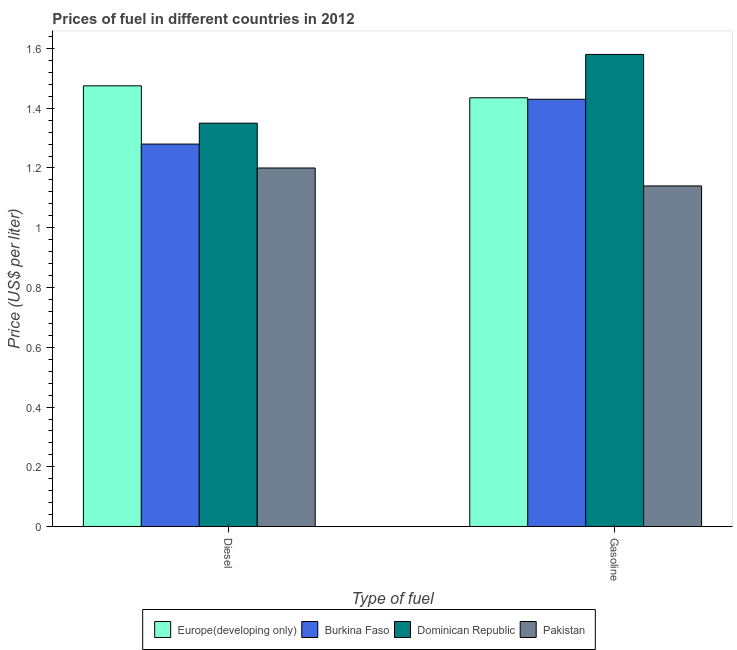How many different coloured bars are there?
Your response must be concise. 4. Are the number of bars per tick equal to the number of legend labels?
Ensure brevity in your answer.  Yes. How many bars are there on the 1st tick from the right?
Make the answer very short. 4. What is the label of the 2nd group of bars from the left?
Your answer should be compact. Gasoline. What is the diesel price in Dominican Republic?
Ensure brevity in your answer.  1.35. Across all countries, what is the maximum gasoline price?
Provide a succinct answer. 1.58. Across all countries, what is the minimum diesel price?
Your response must be concise. 1.2. In which country was the gasoline price maximum?
Provide a succinct answer. Dominican Republic. What is the total diesel price in the graph?
Your answer should be compact. 5.31. What is the difference between the gasoline price in Europe(developing only) and that in Dominican Republic?
Your answer should be compact. -0.15. What is the difference between the diesel price in Dominican Republic and the gasoline price in Europe(developing only)?
Provide a succinct answer. -0.08. What is the average diesel price per country?
Provide a succinct answer. 1.33. What is the difference between the diesel price and gasoline price in Pakistan?
Your response must be concise. 0.06. In how many countries, is the diesel price greater than 0.12 US$ per litre?
Keep it short and to the point. 4. What is the ratio of the gasoline price in Dominican Republic to that in Europe(developing only)?
Give a very brief answer. 1.1. What does the 1st bar from the left in Diesel represents?
Give a very brief answer. Europe(developing only). What does the 3rd bar from the right in Gasoline represents?
Your answer should be very brief. Burkina Faso. How many countries are there in the graph?
Provide a succinct answer. 4. What is the difference between two consecutive major ticks on the Y-axis?
Provide a succinct answer. 0.2. Does the graph contain any zero values?
Your response must be concise. No. What is the title of the graph?
Provide a short and direct response. Prices of fuel in different countries in 2012. Does "Least developed countries" appear as one of the legend labels in the graph?
Offer a terse response. No. What is the label or title of the X-axis?
Provide a short and direct response. Type of fuel. What is the label or title of the Y-axis?
Keep it short and to the point. Price (US$ per liter). What is the Price (US$ per liter) of Europe(developing only) in Diesel?
Offer a very short reply. 1.48. What is the Price (US$ per liter) of Burkina Faso in Diesel?
Offer a very short reply. 1.28. What is the Price (US$ per liter) in Dominican Republic in Diesel?
Provide a short and direct response. 1.35. What is the Price (US$ per liter) of Pakistan in Diesel?
Your answer should be compact. 1.2. What is the Price (US$ per liter) of Europe(developing only) in Gasoline?
Offer a very short reply. 1.44. What is the Price (US$ per liter) of Burkina Faso in Gasoline?
Provide a short and direct response. 1.43. What is the Price (US$ per liter) of Dominican Republic in Gasoline?
Give a very brief answer. 1.58. What is the Price (US$ per liter) in Pakistan in Gasoline?
Your answer should be very brief. 1.14. Across all Type of fuel, what is the maximum Price (US$ per liter) in Europe(developing only)?
Keep it short and to the point. 1.48. Across all Type of fuel, what is the maximum Price (US$ per liter) in Burkina Faso?
Your response must be concise. 1.43. Across all Type of fuel, what is the maximum Price (US$ per liter) in Dominican Republic?
Offer a very short reply. 1.58. Across all Type of fuel, what is the maximum Price (US$ per liter) in Pakistan?
Ensure brevity in your answer.  1.2. Across all Type of fuel, what is the minimum Price (US$ per liter) in Europe(developing only)?
Your response must be concise. 1.44. Across all Type of fuel, what is the minimum Price (US$ per liter) in Burkina Faso?
Provide a short and direct response. 1.28. Across all Type of fuel, what is the minimum Price (US$ per liter) in Dominican Republic?
Keep it short and to the point. 1.35. Across all Type of fuel, what is the minimum Price (US$ per liter) of Pakistan?
Ensure brevity in your answer.  1.14. What is the total Price (US$ per liter) of Europe(developing only) in the graph?
Keep it short and to the point. 2.91. What is the total Price (US$ per liter) in Burkina Faso in the graph?
Your answer should be very brief. 2.71. What is the total Price (US$ per liter) of Dominican Republic in the graph?
Keep it short and to the point. 2.93. What is the total Price (US$ per liter) of Pakistan in the graph?
Your answer should be very brief. 2.34. What is the difference between the Price (US$ per liter) of Dominican Republic in Diesel and that in Gasoline?
Your answer should be very brief. -0.23. What is the difference between the Price (US$ per liter) in Europe(developing only) in Diesel and the Price (US$ per liter) in Burkina Faso in Gasoline?
Your answer should be compact. 0.04. What is the difference between the Price (US$ per liter) of Europe(developing only) in Diesel and the Price (US$ per liter) of Dominican Republic in Gasoline?
Your response must be concise. -0.1. What is the difference between the Price (US$ per liter) in Europe(developing only) in Diesel and the Price (US$ per liter) in Pakistan in Gasoline?
Provide a short and direct response. 0.34. What is the difference between the Price (US$ per liter) in Burkina Faso in Diesel and the Price (US$ per liter) in Dominican Republic in Gasoline?
Offer a terse response. -0.3. What is the difference between the Price (US$ per liter) of Burkina Faso in Diesel and the Price (US$ per liter) of Pakistan in Gasoline?
Provide a short and direct response. 0.14. What is the difference between the Price (US$ per liter) of Dominican Republic in Diesel and the Price (US$ per liter) of Pakistan in Gasoline?
Your response must be concise. 0.21. What is the average Price (US$ per liter) in Europe(developing only) per Type of fuel?
Offer a very short reply. 1.46. What is the average Price (US$ per liter) of Burkina Faso per Type of fuel?
Your answer should be very brief. 1.35. What is the average Price (US$ per liter) of Dominican Republic per Type of fuel?
Ensure brevity in your answer.  1.47. What is the average Price (US$ per liter) of Pakistan per Type of fuel?
Your answer should be compact. 1.17. What is the difference between the Price (US$ per liter) in Europe(developing only) and Price (US$ per liter) in Burkina Faso in Diesel?
Provide a succinct answer. 0.2. What is the difference between the Price (US$ per liter) in Europe(developing only) and Price (US$ per liter) in Dominican Republic in Diesel?
Keep it short and to the point. 0.12. What is the difference between the Price (US$ per liter) in Europe(developing only) and Price (US$ per liter) in Pakistan in Diesel?
Offer a terse response. 0.28. What is the difference between the Price (US$ per liter) of Burkina Faso and Price (US$ per liter) of Dominican Republic in Diesel?
Ensure brevity in your answer.  -0.07. What is the difference between the Price (US$ per liter) of Burkina Faso and Price (US$ per liter) of Pakistan in Diesel?
Your answer should be very brief. 0.08. What is the difference between the Price (US$ per liter) in Europe(developing only) and Price (US$ per liter) in Burkina Faso in Gasoline?
Provide a short and direct response. 0.01. What is the difference between the Price (US$ per liter) of Europe(developing only) and Price (US$ per liter) of Dominican Republic in Gasoline?
Provide a succinct answer. -0.14. What is the difference between the Price (US$ per liter) of Europe(developing only) and Price (US$ per liter) of Pakistan in Gasoline?
Offer a terse response. 0.29. What is the difference between the Price (US$ per liter) of Burkina Faso and Price (US$ per liter) of Pakistan in Gasoline?
Ensure brevity in your answer.  0.29. What is the difference between the Price (US$ per liter) of Dominican Republic and Price (US$ per liter) of Pakistan in Gasoline?
Provide a short and direct response. 0.44. What is the ratio of the Price (US$ per liter) of Europe(developing only) in Diesel to that in Gasoline?
Provide a short and direct response. 1.03. What is the ratio of the Price (US$ per liter) in Burkina Faso in Diesel to that in Gasoline?
Make the answer very short. 0.9. What is the ratio of the Price (US$ per liter) in Dominican Republic in Diesel to that in Gasoline?
Give a very brief answer. 0.85. What is the ratio of the Price (US$ per liter) of Pakistan in Diesel to that in Gasoline?
Your answer should be very brief. 1.05. What is the difference between the highest and the second highest Price (US$ per liter) in Europe(developing only)?
Your response must be concise. 0.04. What is the difference between the highest and the second highest Price (US$ per liter) of Burkina Faso?
Ensure brevity in your answer.  0.15. What is the difference between the highest and the second highest Price (US$ per liter) of Dominican Republic?
Ensure brevity in your answer.  0.23. What is the difference between the highest and the second highest Price (US$ per liter) of Pakistan?
Provide a succinct answer. 0.06. What is the difference between the highest and the lowest Price (US$ per liter) of Europe(developing only)?
Provide a short and direct response. 0.04. What is the difference between the highest and the lowest Price (US$ per liter) in Dominican Republic?
Provide a short and direct response. 0.23. What is the difference between the highest and the lowest Price (US$ per liter) of Pakistan?
Keep it short and to the point. 0.06. 